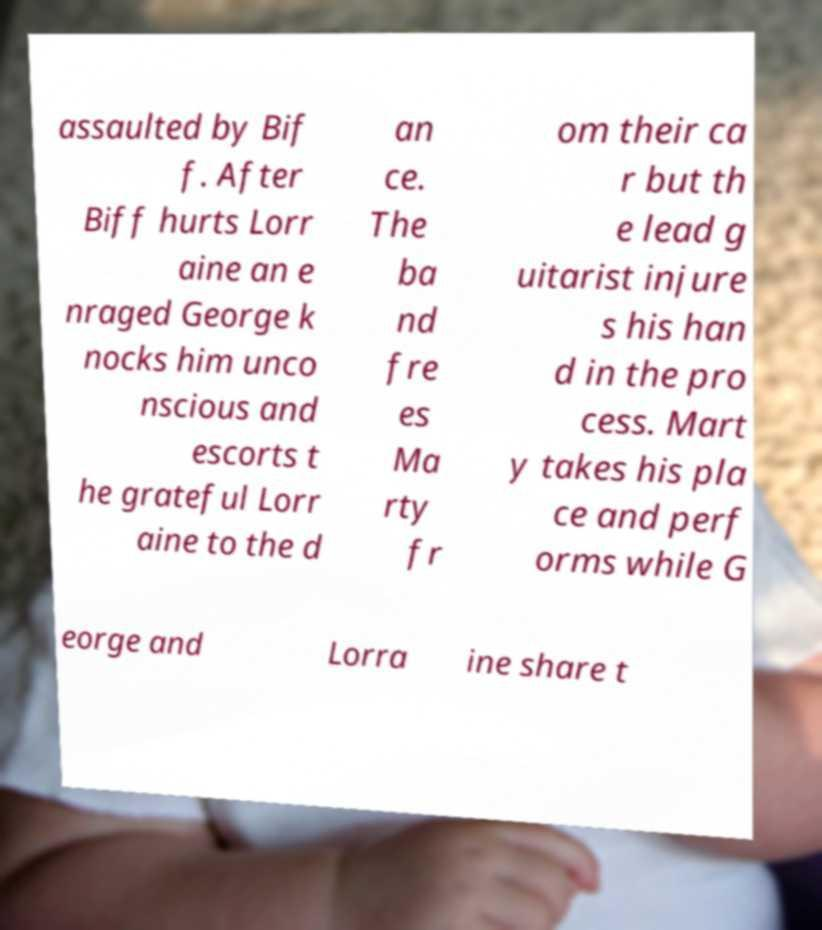Please read and relay the text visible in this image. What does it say? assaulted by Bif f. After Biff hurts Lorr aine an e nraged George k nocks him unco nscious and escorts t he grateful Lorr aine to the d an ce. The ba nd fre es Ma rty fr om their ca r but th e lead g uitarist injure s his han d in the pro cess. Mart y takes his pla ce and perf orms while G eorge and Lorra ine share t 